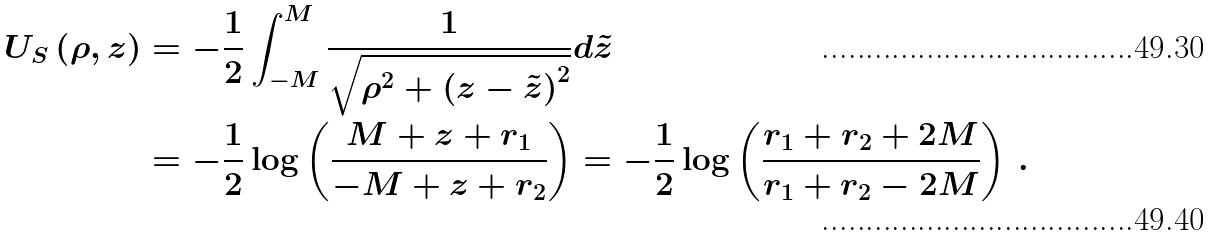Convert formula to latex. <formula><loc_0><loc_0><loc_500><loc_500>U _ { S } \left ( \rho , z \right ) & = - \frac { 1 } { 2 } \int _ { - M } ^ { M } \frac { 1 } { \sqrt { \rho ^ { 2 } + \left ( z - \tilde { z } \right ) ^ { 2 } } } d \tilde { z } \\ & = - \frac { 1 } { 2 } \log \left ( \frac { M + z + r _ { 1 } } { - M + z + r _ { 2 } } \right ) = - \frac { 1 } { 2 } \log \left ( \frac { r _ { 1 } + r _ { 2 } + 2 M } { r _ { 1 } + r _ { 2 } - 2 M } \right ) \, .</formula> 